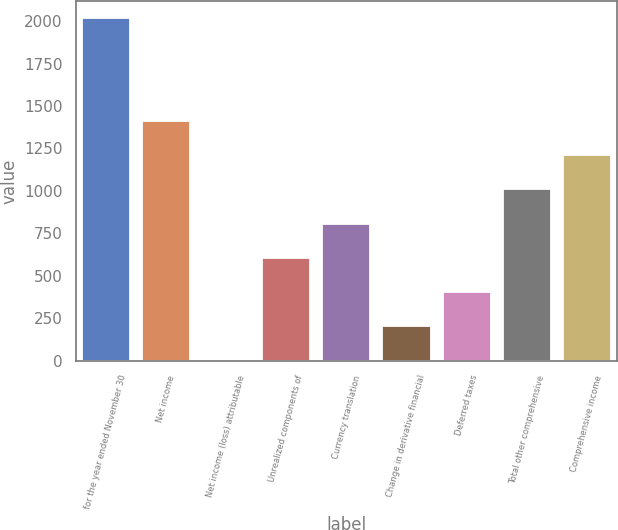<chart> <loc_0><loc_0><loc_500><loc_500><bar_chart><fcel>for the year ended November 30<fcel>Net income<fcel>Net income (loss) attributable<fcel>Unrealized components of<fcel>Currency translation<fcel>Change in derivative financial<fcel>Deferred taxes<fcel>Total other comprehensive<fcel>Comprehensive income<nl><fcel>2016<fcel>1411.59<fcel>1.3<fcel>605.71<fcel>807.18<fcel>202.77<fcel>404.24<fcel>1008.65<fcel>1210.12<nl></chart> 